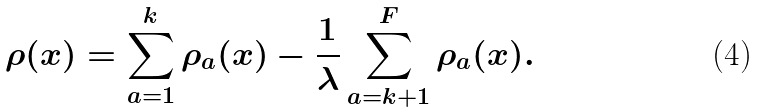Convert formula to latex. <formula><loc_0><loc_0><loc_500><loc_500>\rho ( x ) = \sum _ { a = 1 } ^ { k } \rho _ { a } ( x ) - \frac { 1 } { \lambda } \sum _ { a = k + 1 } ^ { F } \rho _ { a } ( x ) .</formula> 